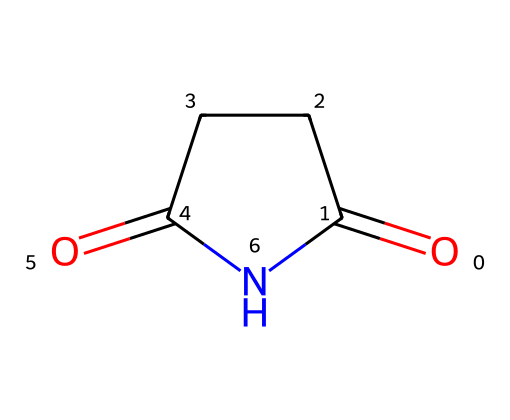What is the name of this chemical? The SMILES representation identifies the compound as succinimide, which is a specific type of imide. It includes a five-membered ring with two carbonyl groups and an amine.
Answer: succinimide How many carbon atoms are present in succinimide? By analyzing the structure, there are four carbon atoms present in the ring structure and the two carbonyl groups, totaling four.
Answer: 4 What functional groups are present in succinimide? The structure shows two carbonyl groups (C=O) and a nitrogen atom (N) in the imide group, indicating the presence of imide functionalities.
Answer: carbonyl and imide How many hydrogen atoms are in succinimide? The structure illustrates that each carbon is bonded to enough hydrogen atoms to satisfy carbon's tetravalency, resulting in a total of six hydrogen atoms in the compound.
Answer: 6 What is the total number of bonds in succinimide? Counting the bonds visible in the structure: there are eight single bonds (C-N and C-H bonds) and two double bonds (C=O), which sums up to ten bonds total.
Answer: 10 Which part of the succinimide structure forms the imide functional group? The imide functional group is characterized by the nitrogen atom bonded to two carbonyl carbon atoms, specifically noted in this SMILES notation.
Answer: nitrogen bonded to carbonyls What type of applications is succinimide primarily used for? Succinimide is often utilized as a derivative in fabric softeners and conditioners due to its properties, allowing it to improve the texture and feel of fabrics.
Answer: fabric softeners 